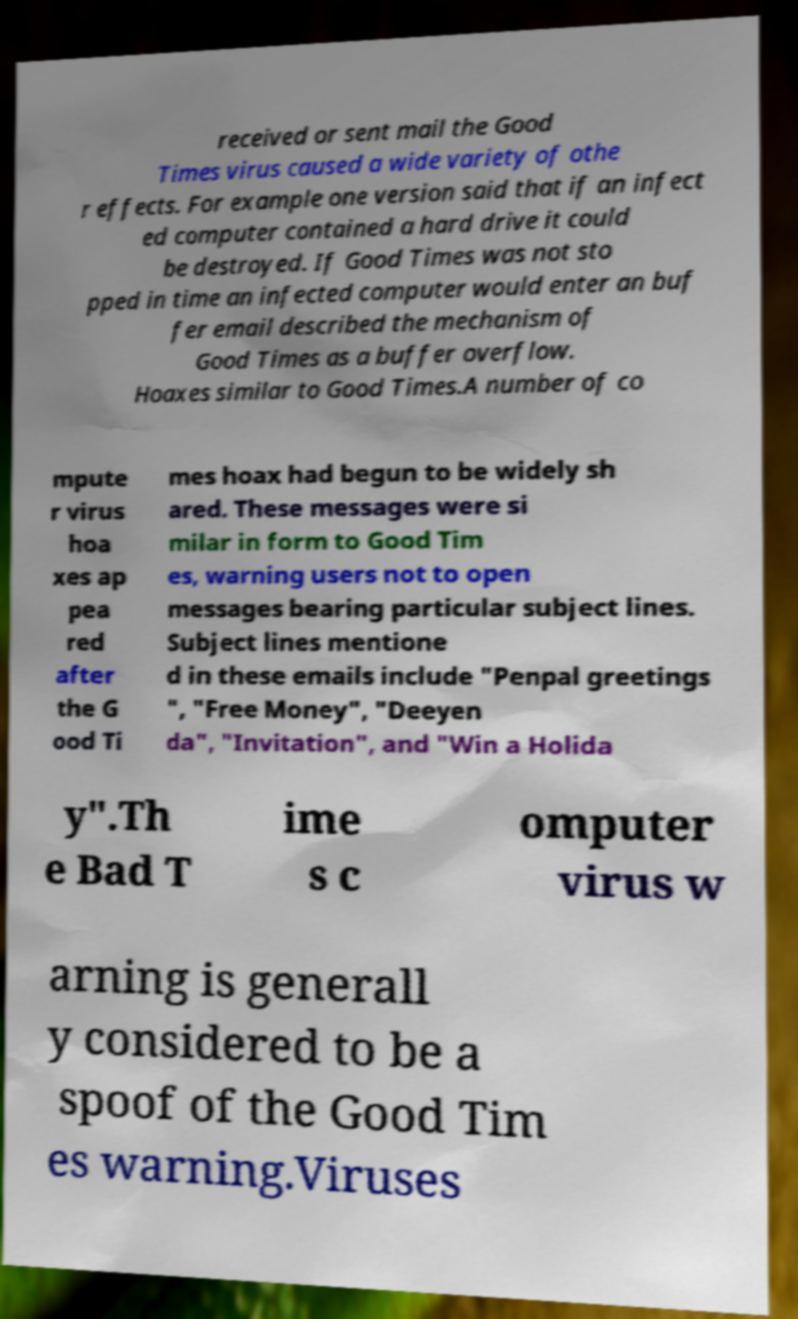Please identify and transcribe the text found in this image. received or sent mail the Good Times virus caused a wide variety of othe r effects. For example one version said that if an infect ed computer contained a hard drive it could be destroyed. If Good Times was not sto pped in time an infected computer would enter an buf fer email described the mechanism of Good Times as a buffer overflow. Hoaxes similar to Good Times.A number of co mpute r virus hoa xes ap pea red after the G ood Ti mes hoax had begun to be widely sh ared. These messages were si milar in form to Good Tim es, warning users not to open messages bearing particular subject lines. Subject lines mentione d in these emails include "Penpal greetings ", "Free Money", "Deeyen da", "Invitation", and "Win a Holida y".Th e Bad T ime s c omputer virus w arning is generall y considered to be a spoof of the Good Tim es warning.Viruses 